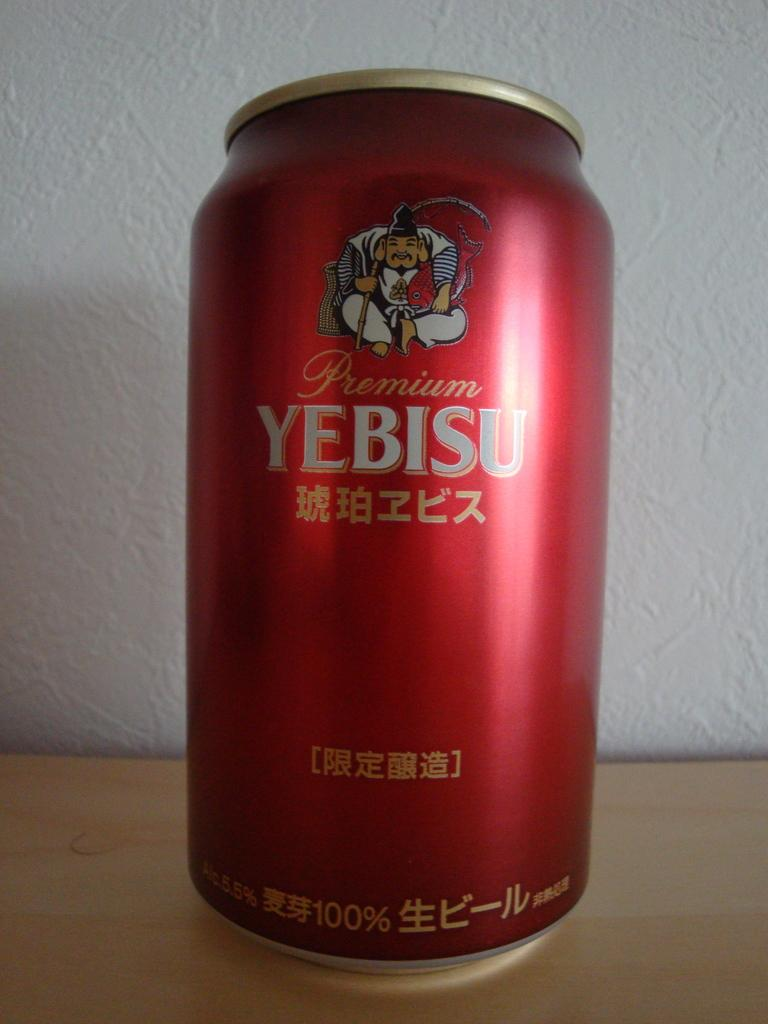<image>
Describe the image concisely. Red beer can which says "YEBISU" on the front. 